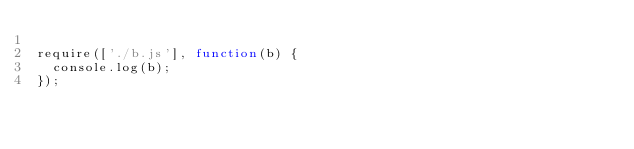<code> <loc_0><loc_0><loc_500><loc_500><_JavaScript_>
require(['./b.js'], function(b) {
  console.log(b);
});
</code> 